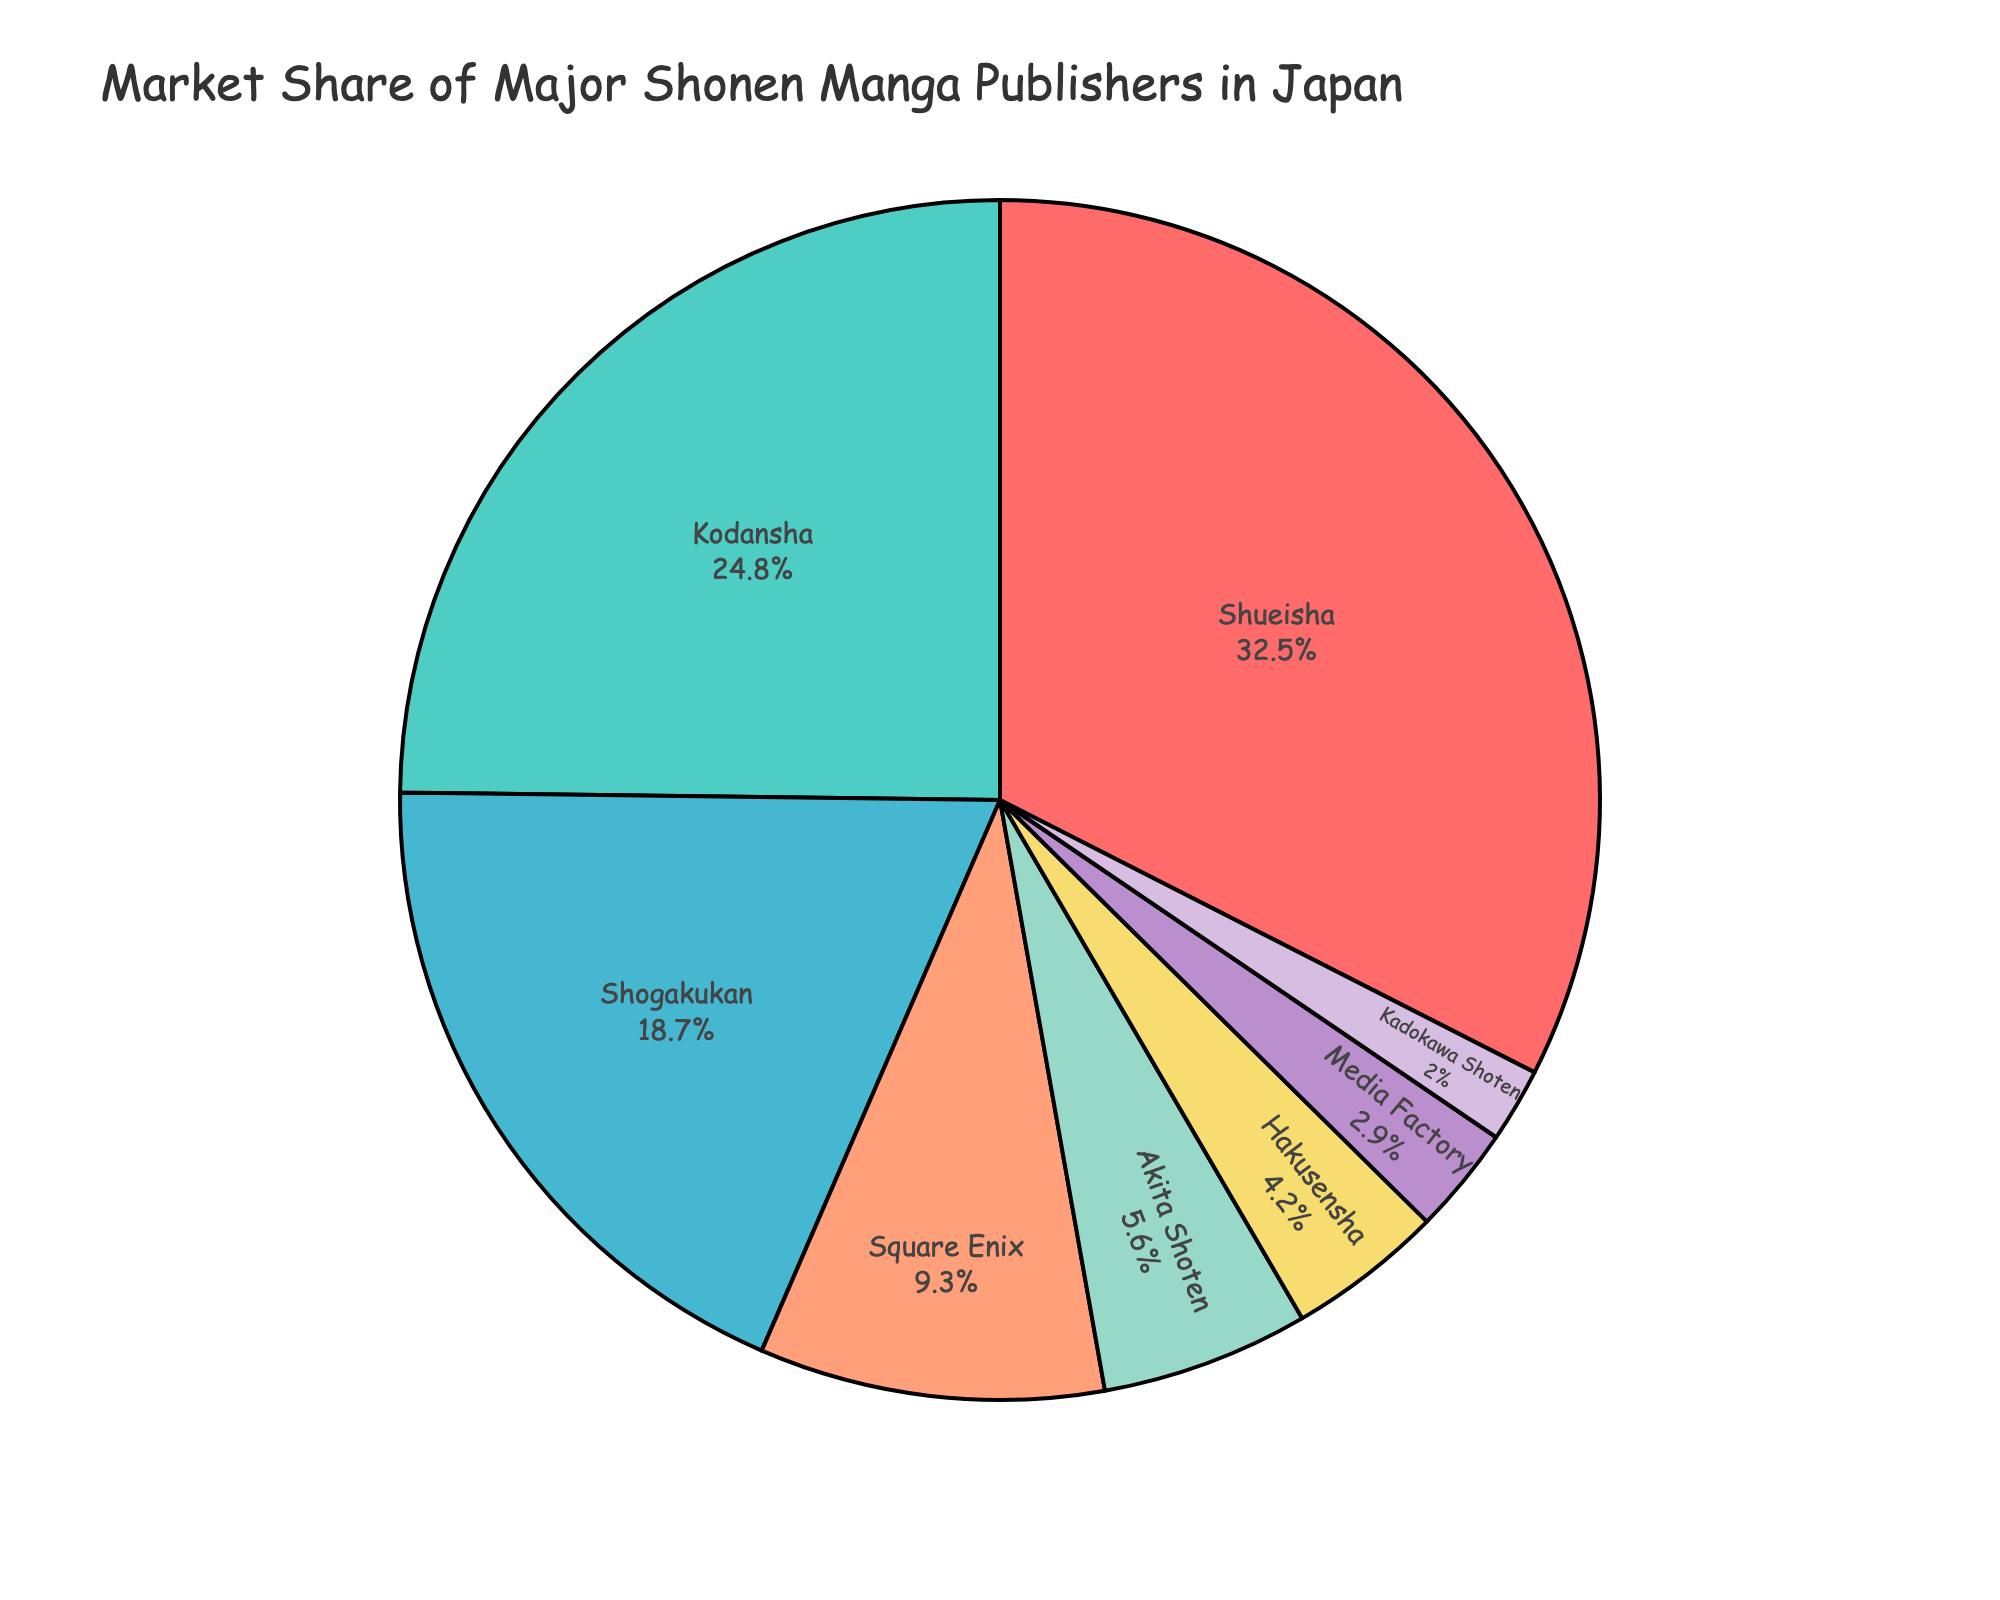Which publisher has the highest market share? By looking at the pie chart, the segment representing Shueisha is the largest, corresponding to a market share of 32.5%.
Answer: Shueisha Which publisher has a market share smaller than 5% but larger than 2%? From the pie chart, we identify two segments that fall in this range: Hakusensha (4.2%) and Media Factory (2.9%).
Answer: Hakusensha and Media Factory How much more market share does Shueisha have compared to Shogakukan? Shueisha has a market share of 32.5%, and Shogakukan has 18.7%. The difference is calculated as 32.5% - 18.7% = 13.8%.
Answer: 13.8% Which publisher has the smallest market share and what is it? The smallest segment in the pie chart corresponds to Kadokawa Shoten, which has a market share of 2.0%.
Answer: Kadokawa Shoten, 2.0% What is the combined market share of Shogakukan and Kodansha? Shogakukan's market share is 18.7%, and Kodansha's is 24.8%. Summing these, we get 18.7% + 24.8% = 43.5%.
Answer: 43.5% How does the market share of Square Enix compare to that of Akita Shoten? Square Enix has a market share of 9.3%, while Akita Shoten has 5.6%. Therefore, Square Enix's market share is greater than Akita Shoten's by 9.3% - 5.6% = 3.7%.
Answer: Square Enix's market share is 3.7% greater Which publisher is represented by the orange color? Observing the colors in the pie chart, the orange section corresponds to Square Enix with a market share of 9.3%.
Answer: Square Enix What is the sum of the market shares of all publishers except Shueisha? To find the total market share excluding Shueisha's 32.5%, we sum the remaining shares: 24.8% (Kodansha) + 18.7% (Shogakukan) + 9.3% (Square Enix) + 5.6% (Akita Shoten) + 4.2% (Hakusensha) + 2.9% (Media Factory) + 2.0% (Kadokawa Shoten) = 67.5%.
Answer: 67.5% Which two publishers together make up more than half of the total market share? Shueisha has 32.5% and Kodansha has 24.8%. Their combined share is 32.5% + 24.8% = 57.3%, which is more than half of the total market share.
Answer: Shueisha and Kodansha How does the market share of Media Factory compare to that of Hakusensha? Media Factory has a market share of 2.9%, whereas Hakusensha has 4.2%. Thus, Hakusensha's market share is greater by 4.2% - 2.9% = 1.3%.
Answer: Hakusensha's market share is 1.3% greater 